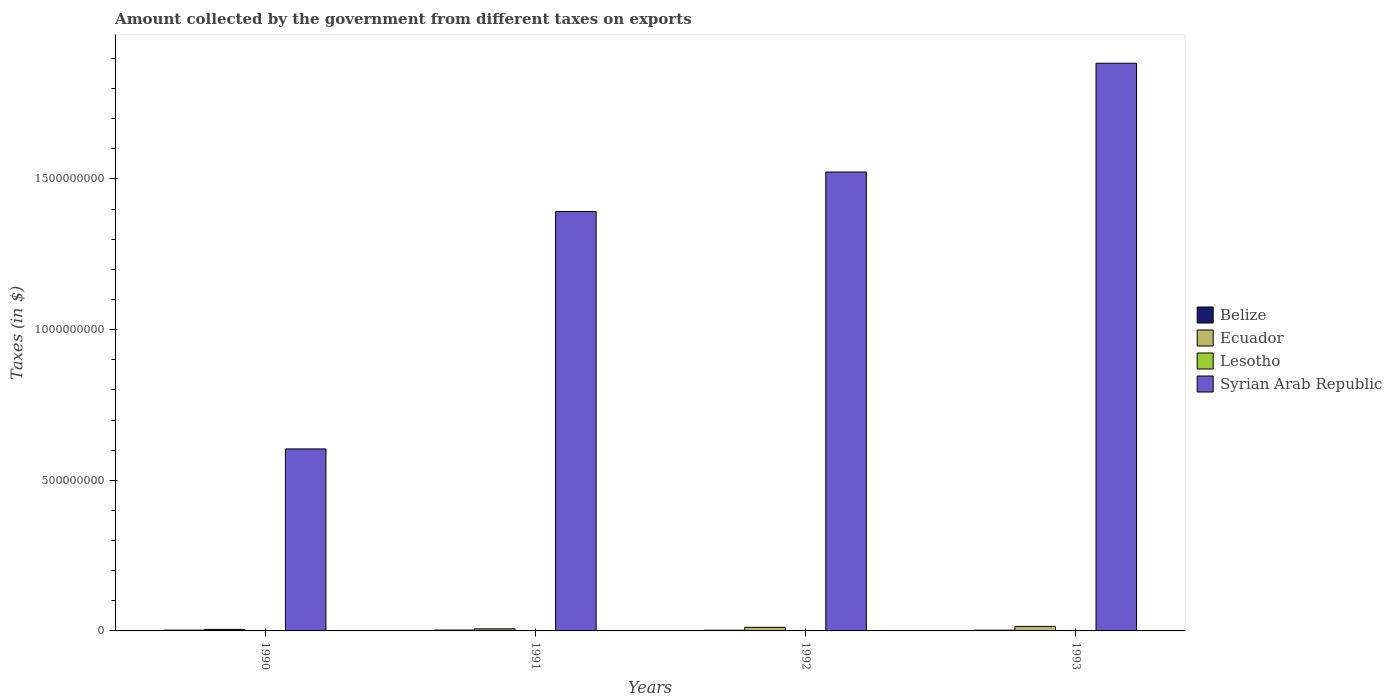How many different coloured bars are there?
Your answer should be very brief. 4. Are the number of bars per tick equal to the number of legend labels?
Make the answer very short. Yes. What is the label of the 1st group of bars from the left?
Your answer should be very brief. 1990. In how many cases, is the number of bars for a given year not equal to the number of legend labels?
Give a very brief answer. 0. What is the amount collected by the government from taxes on exports in Belize in 1993?
Ensure brevity in your answer.  2.45e+06. Across all years, what is the maximum amount collected by the government from taxes on exports in Ecuador?
Offer a very short reply. 1.50e+07. Across all years, what is the minimum amount collected by the government from taxes on exports in Belize?
Provide a short and direct response. 2.34e+06. In which year was the amount collected by the government from taxes on exports in Syrian Arab Republic maximum?
Offer a terse response. 1993. In which year was the amount collected by the government from taxes on exports in Ecuador minimum?
Your answer should be compact. 1990. What is the total amount collected by the government from taxes on exports in Ecuador in the graph?
Ensure brevity in your answer.  3.90e+07. What is the difference between the amount collected by the government from taxes on exports in Belize in 1991 and that in 1992?
Give a very brief answer. 5.07e+05. What is the difference between the amount collected by the government from taxes on exports in Lesotho in 1992 and the amount collected by the government from taxes on exports in Syrian Arab Republic in 1993?
Offer a very short reply. -1.88e+09. What is the average amount collected by the government from taxes on exports in Syrian Arab Republic per year?
Give a very brief answer. 1.35e+09. In the year 1993, what is the difference between the amount collected by the government from taxes on exports in Syrian Arab Republic and amount collected by the government from taxes on exports in Belize?
Offer a terse response. 1.88e+09. In how many years, is the amount collected by the government from taxes on exports in Lesotho greater than 200000000 $?
Ensure brevity in your answer.  0. What is the ratio of the amount collected by the government from taxes on exports in Belize in 1991 to that in 1993?
Give a very brief answer. 1.16. Is the difference between the amount collected by the government from taxes on exports in Syrian Arab Republic in 1990 and 1991 greater than the difference between the amount collected by the government from taxes on exports in Belize in 1990 and 1991?
Offer a terse response. No. What is the difference between the highest and the lowest amount collected by the government from taxes on exports in Syrian Arab Republic?
Offer a very short reply. 1.28e+09. Is it the case that in every year, the sum of the amount collected by the government from taxes on exports in Syrian Arab Republic and amount collected by the government from taxes on exports in Ecuador is greater than the sum of amount collected by the government from taxes on exports in Lesotho and amount collected by the government from taxes on exports in Belize?
Your answer should be very brief. Yes. What does the 4th bar from the left in 1993 represents?
Give a very brief answer. Syrian Arab Republic. What does the 1st bar from the right in 1990 represents?
Offer a terse response. Syrian Arab Republic. Is it the case that in every year, the sum of the amount collected by the government from taxes on exports in Ecuador and amount collected by the government from taxes on exports in Lesotho is greater than the amount collected by the government from taxes on exports in Syrian Arab Republic?
Offer a terse response. No. How many years are there in the graph?
Offer a very short reply. 4. What is the difference between two consecutive major ticks on the Y-axis?
Make the answer very short. 5.00e+08. Does the graph contain any zero values?
Provide a succinct answer. No. Does the graph contain grids?
Your response must be concise. No. How many legend labels are there?
Your answer should be compact. 4. What is the title of the graph?
Keep it short and to the point. Amount collected by the government from different taxes on exports. What is the label or title of the Y-axis?
Keep it short and to the point. Taxes (in $). What is the Taxes (in $) in Belize in 1990?
Offer a very short reply. 2.60e+06. What is the Taxes (in $) in Lesotho in 1990?
Offer a very short reply. 9.85e+05. What is the Taxes (in $) of Syrian Arab Republic in 1990?
Make the answer very short. 6.04e+08. What is the Taxes (in $) in Belize in 1991?
Your answer should be very brief. 2.84e+06. What is the Taxes (in $) of Ecuador in 1991?
Make the answer very short. 7.00e+06. What is the Taxes (in $) of Lesotho in 1991?
Keep it short and to the point. 3.36e+05. What is the Taxes (in $) of Syrian Arab Republic in 1991?
Provide a short and direct response. 1.39e+09. What is the Taxes (in $) in Belize in 1992?
Your answer should be very brief. 2.34e+06. What is the Taxes (in $) in Ecuador in 1992?
Ensure brevity in your answer.  1.20e+07. What is the Taxes (in $) of Lesotho in 1992?
Give a very brief answer. 2.14e+05. What is the Taxes (in $) of Syrian Arab Republic in 1992?
Your response must be concise. 1.52e+09. What is the Taxes (in $) of Belize in 1993?
Offer a terse response. 2.45e+06. What is the Taxes (in $) in Ecuador in 1993?
Provide a succinct answer. 1.50e+07. What is the Taxes (in $) in Lesotho in 1993?
Keep it short and to the point. 3.65e+05. What is the Taxes (in $) in Syrian Arab Republic in 1993?
Keep it short and to the point. 1.88e+09. Across all years, what is the maximum Taxes (in $) in Belize?
Your answer should be compact. 2.84e+06. Across all years, what is the maximum Taxes (in $) of Ecuador?
Your answer should be very brief. 1.50e+07. Across all years, what is the maximum Taxes (in $) in Lesotho?
Your response must be concise. 9.85e+05. Across all years, what is the maximum Taxes (in $) of Syrian Arab Republic?
Offer a terse response. 1.88e+09. Across all years, what is the minimum Taxes (in $) of Belize?
Keep it short and to the point. 2.34e+06. Across all years, what is the minimum Taxes (in $) of Ecuador?
Give a very brief answer. 5.00e+06. Across all years, what is the minimum Taxes (in $) of Lesotho?
Your response must be concise. 2.14e+05. Across all years, what is the minimum Taxes (in $) in Syrian Arab Republic?
Provide a short and direct response. 6.04e+08. What is the total Taxes (in $) in Belize in the graph?
Ensure brevity in your answer.  1.02e+07. What is the total Taxes (in $) in Ecuador in the graph?
Provide a short and direct response. 3.90e+07. What is the total Taxes (in $) of Lesotho in the graph?
Your response must be concise. 1.90e+06. What is the total Taxes (in $) in Syrian Arab Republic in the graph?
Your answer should be compact. 5.40e+09. What is the difference between the Taxes (in $) in Belize in 1990 and that in 1991?
Provide a short and direct response. -2.42e+05. What is the difference between the Taxes (in $) in Ecuador in 1990 and that in 1991?
Give a very brief answer. -2.00e+06. What is the difference between the Taxes (in $) of Lesotho in 1990 and that in 1991?
Offer a terse response. 6.49e+05. What is the difference between the Taxes (in $) of Syrian Arab Republic in 1990 and that in 1991?
Provide a succinct answer. -7.88e+08. What is the difference between the Taxes (in $) in Belize in 1990 and that in 1992?
Your response must be concise. 2.65e+05. What is the difference between the Taxes (in $) of Ecuador in 1990 and that in 1992?
Ensure brevity in your answer.  -7.00e+06. What is the difference between the Taxes (in $) of Lesotho in 1990 and that in 1992?
Keep it short and to the point. 7.71e+05. What is the difference between the Taxes (in $) of Syrian Arab Republic in 1990 and that in 1992?
Ensure brevity in your answer.  -9.19e+08. What is the difference between the Taxes (in $) of Belize in 1990 and that in 1993?
Give a very brief answer. 1.48e+05. What is the difference between the Taxes (in $) in Ecuador in 1990 and that in 1993?
Keep it short and to the point. -1.00e+07. What is the difference between the Taxes (in $) of Lesotho in 1990 and that in 1993?
Provide a succinct answer. 6.20e+05. What is the difference between the Taxes (in $) of Syrian Arab Republic in 1990 and that in 1993?
Make the answer very short. -1.28e+09. What is the difference between the Taxes (in $) in Belize in 1991 and that in 1992?
Provide a succinct answer. 5.07e+05. What is the difference between the Taxes (in $) of Ecuador in 1991 and that in 1992?
Ensure brevity in your answer.  -5.00e+06. What is the difference between the Taxes (in $) in Lesotho in 1991 and that in 1992?
Make the answer very short. 1.22e+05. What is the difference between the Taxes (in $) in Syrian Arab Republic in 1991 and that in 1992?
Provide a succinct answer. -1.31e+08. What is the difference between the Taxes (in $) in Belize in 1991 and that in 1993?
Your answer should be compact. 3.90e+05. What is the difference between the Taxes (in $) of Ecuador in 1991 and that in 1993?
Give a very brief answer. -8.00e+06. What is the difference between the Taxes (in $) in Lesotho in 1991 and that in 1993?
Provide a short and direct response. -2.90e+04. What is the difference between the Taxes (in $) of Syrian Arab Republic in 1991 and that in 1993?
Provide a succinct answer. -4.92e+08. What is the difference between the Taxes (in $) in Belize in 1992 and that in 1993?
Your answer should be very brief. -1.17e+05. What is the difference between the Taxes (in $) in Lesotho in 1992 and that in 1993?
Offer a very short reply. -1.51e+05. What is the difference between the Taxes (in $) of Syrian Arab Republic in 1992 and that in 1993?
Your answer should be compact. -3.61e+08. What is the difference between the Taxes (in $) of Belize in 1990 and the Taxes (in $) of Ecuador in 1991?
Keep it short and to the point. -4.40e+06. What is the difference between the Taxes (in $) in Belize in 1990 and the Taxes (in $) in Lesotho in 1991?
Provide a succinct answer. 2.26e+06. What is the difference between the Taxes (in $) in Belize in 1990 and the Taxes (in $) in Syrian Arab Republic in 1991?
Give a very brief answer. -1.39e+09. What is the difference between the Taxes (in $) of Ecuador in 1990 and the Taxes (in $) of Lesotho in 1991?
Keep it short and to the point. 4.66e+06. What is the difference between the Taxes (in $) in Ecuador in 1990 and the Taxes (in $) in Syrian Arab Republic in 1991?
Make the answer very short. -1.39e+09. What is the difference between the Taxes (in $) of Lesotho in 1990 and the Taxes (in $) of Syrian Arab Republic in 1991?
Provide a succinct answer. -1.39e+09. What is the difference between the Taxes (in $) in Belize in 1990 and the Taxes (in $) in Ecuador in 1992?
Make the answer very short. -9.40e+06. What is the difference between the Taxes (in $) of Belize in 1990 and the Taxes (in $) of Lesotho in 1992?
Offer a very short reply. 2.39e+06. What is the difference between the Taxes (in $) in Belize in 1990 and the Taxes (in $) in Syrian Arab Republic in 1992?
Your answer should be compact. -1.52e+09. What is the difference between the Taxes (in $) of Ecuador in 1990 and the Taxes (in $) of Lesotho in 1992?
Provide a succinct answer. 4.79e+06. What is the difference between the Taxes (in $) of Ecuador in 1990 and the Taxes (in $) of Syrian Arab Republic in 1992?
Ensure brevity in your answer.  -1.52e+09. What is the difference between the Taxes (in $) in Lesotho in 1990 and the Taxes (in $) in Syrian Arab Republic in 1992?
Make the answer very short. -1.52e+09. What is the difference between the Taxes (in $) of Belize in 1990 and the Taxes (in $) of Ecuador in 1993?
Your response must be concise. -1.24e+07. What is the difference between the Taxes (in $) of Belize in 1990 and the Taxes (in $) of Lesotho in 1993?
Your answer should be very brief. 2.24e+06. What is the difference between the Taxes (in $) of Belize in 1990 and the Taxes (in $) of Syrian Arab Republic in 1993?
Give a very brief answer. -1.88e+09. What is the difference between the Taxes (in $) of Ecuador in 1990 and the Taxes (in $) of Lesotho in 1993?
Provide a short and direct response. 4.64e+06. What is the difference between the Taxes (in $) in Ecuador in 1990 and the Taxes (in $) in Syrian Arab Republic in 1993?
Your response must be concise. -1.88e+09. What is the difference between the Taxes (in $) of Lesotho in 1990 and the Taxes (in $) of Syrian Arab Republic in 1993?
Your response must be concise. -1.88e+09. What is the difference between the Taxes (in $) in Belize in 1991 and the Taxes (in $) in Ecuador in 1992?
Make the answer very short. -9.16e+06. What is the difference between the Taxes (in $) of Belize in 1991 and the Taxes (in $) of Lesotho in 1992?
Provide a succinct answer. 2.63e+06. What is the difference between the Taxes (in $) of Belize in 1991 and the Taxes (in $) of Syrian Arab Republic in 1992?
Give a very brief answer. -1.52e+09. What is the difference between the Taxes (in $) in Ecuador in 1991 and the Taxes (in $) in Lesotho in 1992?
Your response must be concise. 6.79e+06. What is the difference between the Taxes (in $) of Ecuador in 1991 and the Taxes (in $) of Syrian Arab Republic in 1992?
Give a very brief answer. -1.52e+09. What is the difference between the Taxes (in $) in Lesotho in 1991 and the Taxes (in $) in Syrian Arab Republic in 1992?
Your answer should be compact. -1.52e+09. What is the difference between the Taxes (in $) in Belize in 1991 and the Taxes (in $) in Ecuador in 1993?
Your answer should be very brief. -1.22e+07. What is the difference between the Taxes (in $) of Belize in 1991 and the Taxes (in $) of Lesotho in 1993?
Your answer should be very brief. 2.48e+06. What is the difference between the Taxes (in $) in Belize in 1991 and the Taxes (in $) in Syrian Arab Republic in 1993?
Give a very brief answer. -1.88e+09. What is the difference between the Taxes (in $) of Ecuador in 1991 and the Taxes (in $) of Lesotho in 1993?
Keep it short and to the point. 6.64e+06. What is the difference between the Taxes (in $) of Ecuador in 1991 and the Taxes (in $) of Syrian Arab Republic in 1993?
Your response must be concise. -1.88e+09. What is the difference between the Taxes (in $) of Lesotho in 1991 and the Taxes (in $) of Syrian Arab Republic in 1993?
Your answer should be compact. -1.88e+09. What is the difference between the Taxes (in $) of Belize in 1992 and the Taxes (in $) of Ecuador in 1993?
Give a very brief answer. -1.27e+07. What is the difference between the Taxes (in $) of Belize in 1992 and the Taxes (in $) of Lesotho in 1993?
Make the answer very short. 1.97e+06. What is the difference between the Taxes (in $) of Belize in 1992 and the Taxes (in $) of Syrian Arab Republic in 1993?
Ensure brevity in your answer.  -1.88e+09. What is the difference between the Taxes (in $) in Ecuador in 1992 and the Taxes (in $) in Lesotho in 1993?
Ensure brevity in your answer.  1.16e+07. What is the difference between the Taxes (in $) in Ecuador in 1992 and the Taxes (in $) in Syrian Arab Republic in 1993?
Your response must be concise. -1.87e+09. What is the difference between the Taxes (in $) of Lesotho in 1992 and the Taxes (in $) of Syrian Arab Republic in 1993?
Your answer should be very brief. -1.88e+09. What is the average Taxes (in $) of Belize per year?
Keep it short and to the point. 2.56e+06. What is the average Taxes (in $) in Ecuador per year?
Your answer should be very brief. 9.75e+06. What is the average Taxes (in $) of Lesotho per year?
Your answer should be compact. 4.75e+05. What is the average Taxes (in $) in Syrian Arab Republic per year?
Give a very brief answer. 1.35e+09. In the year 1990, what is the difference between the Taxes (in $) in Belize and Taxes (in $) in Ecuador?
Offer a terse response. -2.40e+06. In the year 1990, what is the difference between the Taxes (in $) of Belize and Taxes (in $) of Lesotho?
Give a very brief answer. 1.62e+06. In the year 1990, what is the difference between the Taxes (in $) of Belize and Taxes (in $) of Syrian Arab Republic?
Make the answer very short. -6.01e+08. In the year 1990, what is the difference between the Taxes (in $) in Ecuador and Taxes (in $) in Lesotho?
Provide a short and direct response. 4.02e+06. In the year 1990, what is the difference between the Taxes (in $) of Ecuador and Taxes (in $) of Syrian Arab Republic?
Ensure brevity in your answer.  -5.99e+08. In the year 1990, what is the difference between the Taxes (in $) in Lesotho and Taxes (in $) in Syrian Arab Republic?
Provide a short and direct response. -6.03e+08. In the year 1991, what is the difference between the Taxes (in $) in Belize and Taxes (in $) in Ecuador?
Ensure brevity in your answer.  -4.16e+06. In the year 1991, what is the difference between the Taxes (in $) in Belize and Taxes (in $) in Lesotho?
Ensure brevity in your answer.  2.51e+06. In the year 1991, what is the difference between the Taxes (in $) in Belize and Taxes (in $) in Syrian Arab Republic?
Provide a succinct answer. -1.39e+09. In the year 1991, what is the difference between the Taxes (in $) of Ecuador and Taxes (in $) of Lesotho?
Your answer should be compact. 6.66e+06. In the year 1991, what is the difference between the Taxes (in $) in Ecuador and Taxes (in $) in Syrian Arab Republic?
Your response must be concise. -1.38e+09. In the year 1991, what is the difference between the Taxes (in $) in Lesotho and Taxes (in $) in Syrian Arab Republic?
Give a very brief answer. -1.39e+09. In the year 1992, what is the difference between the Taxes (in $) of Belize and Taxes (in $) of Ecuador?
Offer a terse response. -9.66e+06. In the year 1992, what is the difference between the Taxes (in $) in Belize and Taxes (in $) in Lesotho?
Provide a succinct answer. 2.12e+06. In the year 1992, what is the difference between the Taxes (in $) of Belize and Taxes (in $) of Syrian Arab Republic?
Your answer should be very brief. -1.52e+09. In the year 1992, what is the difference between the Taxes (in $) of Ecuador and Taxes (in $) of Lesotho?
Provide a succinct answer. 1.18e+07. In the year 1992, what is the difference between the Taxes (in $) in Ecuador and Taxes (in $) in Syrian Arab Republic?
Your answer should be very brief. -1.51e+09. In the year 1992, what is the difference between the Taxes (in $) of Lesotho and Taxes (in $) of Syrian Arab Republic?
Your response must be concise. -1.52e+09. In the year 1993, what is the difference between the Taxes (in $) of Belize and Taxes (in $) of Ecuador?
Your answer should be very brief. -1.25e+07. In the year 1993, what is the difference between the Taxes (in $) in Belize and Taxes (in $) in Lesotho?
Your answer should be very brief. 2.09e+06. In the year 1993, what is the difference between the Taxes (in $) in Belize and Taxes (in $) in Syrian Arab Republic?
Provide a short and direct response. -1.88e+09. In the year 1993, what is the difference between the Taxes (in $) in Ecuador and Taxes (in $) in Lesotho?
Offer a very short reply. 1.46e+07. In the year 1993, what is the difference between the Taxes (in $) in Ecuador and Taxes (in $) in Syrian Arab Republic?
Make the answer very short. -1.87e+09. In the year 1993, what is the difference between the Taxes (in $) of Lesotho and Taxes (in $) of Syrian Arab Republic?
Give a very brief answer. -1.88e+09. What is the ratio of the Taxes (in $) in Belize in 1990 to that in 1991?
Provide a short and direct response. 0.91. What is the ratio of the Taxes (in $) of Ecuador in 1990 to that in 1991?
Offer a very short reply. 0.71. What is the ratio of the Taxes (in $) of Lesotho in 1990 to that in 1991?
Ensure brevity in your answer.  2.93. What is the ratio of the Taxes (in $) of Syrian Arab Republic in 1990 to that in 1991?
Offer a very short reply. 0.43. What is the ratio of the Taxes (in $) in Belize in 1990 to that in 1992?
Provide a short and direct response. 1.11. What is the ratio of the Taxes (in $) of Ecuador in 1990 to that in 1992?
Ensure brevity in your answer.  0.42. What is the ratio of the Taxes (in $) of Lesotho in 1990 to that in 1992?
Your answer should be compact. 4.6. What is the ratio of the Taxes (in $) in Syrian Arab Republic in 1990 to that in 1992?
Give a very brief answer. 0.4. What is the ratio of the Taxes (in $) in Belize in 1990 to that in 1993?
Make the answer very short. 1.06. What is the ratio of the Taxes (in $) in Ecuador in 1990 to that in 1993?
Offer a terse response. 0.33. What is the ratio of the Taxes (in $) of Lesotho in 1990 to that in 1993?
Offer a terse response. 2.7. What is the ratio of the Taxes (in $) in Syrian Arab Republic in 1990 to that in 1993?
Provide a short and direct response. 0.32. What is the ratio of the Taxes (in $) in Belize in 1991 to that in 1992?
Give a very brief answer. 1.22. What is the ratio of the Taxes (in $) of Ecuador in 1991 to that in 1992?
Give a very brief answer. 0.58. What is the ratio of the Taxes (in $) of Lesotho in 1991 to that in 1992?
Ensure brevity in your answer.  1.57. What is the ratio of the Taxes (in $) of Syrian Arab Republic in 1991 to that in 1992?
Keep it short and to the point. 0.91. What is the ratio of the Taxes (in $) in Belize in 1991 to that in 1993?
Ensure brevity in your answer.  1.16. What is the ratio of the Taxes (in $) of Ecuador in 1991 to that in 1993?
Provide a short and direct response. 0.47. What is the ratio of the Taxes (in $) in Lesotho in 1991 to that in 1993?
Ensure brevity in your answer.  0.92. What is the ratio of the Taxes (in $) of Syrian Arab Republic in 1991 to that in 1993?
Offer a very short reply. 0.74. What is the ratio of the Taxes (in $) in Belize in 1992 to that in 1993?
Your answer should be compact. 0.95. What is the ratio of the Taxes (in $) in Ecuador in 1992 to that in 1993?
Make the answer very short. 0.8. What is the ratio of the Taxes (in $) in Lesotho in 1992 to that in 1993?
Your answer should be compact. 0.59. What is the ratio of the Taxes (in $) of Syrian Arab Republic in 1992 to that in 1993?
Your response must be concise. 0.81. What is the difference between the highest and the second highest Taxes (in $) in Belize?
Make the answer very short. 2.42e+05. What is the difference between the highest and the second highest Taxes (in $) in Ecuador?
Your answer should be very brief. 3.00e+06. What is the difference between the highest and the second highest Taxes (in $) of Lesotho?
Ensure brevity in your answer.  6.20e+05. What is the difference between the highest and the second highest Taxes (in $) of Syrian Arab Republic?
Offer a very short reply. 3.61e+08. What is the difference between the highest and the lowest Taxes (in $) in Belize?
Make the answer very short. 5.07e+05. What is the difference between the highest and the lowest Taxes (in $) in Lesotho?
Make the answer very short. 7.71e+05. What is the difference between the highest and the lowest Taxes (in $) in Syrian Arab Republic?
Provide a succinct answer. 1.28e+09. 